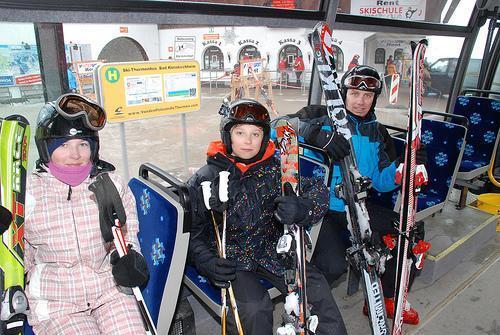How many skiers are wearing blue jackets?
Give a very brief answer. 1. 